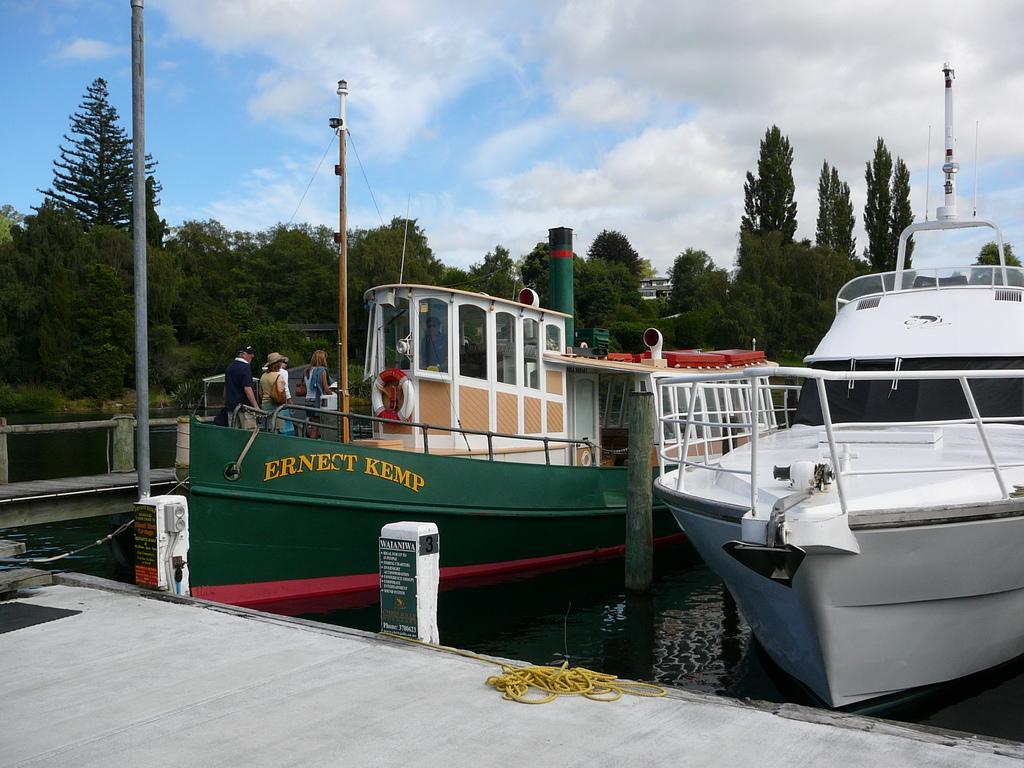Could you give a brief overview of what you see in this image? In the image there is a wooden surface, beside that there are two ships and there are few people on the first ship, around the ships there are many trees. 